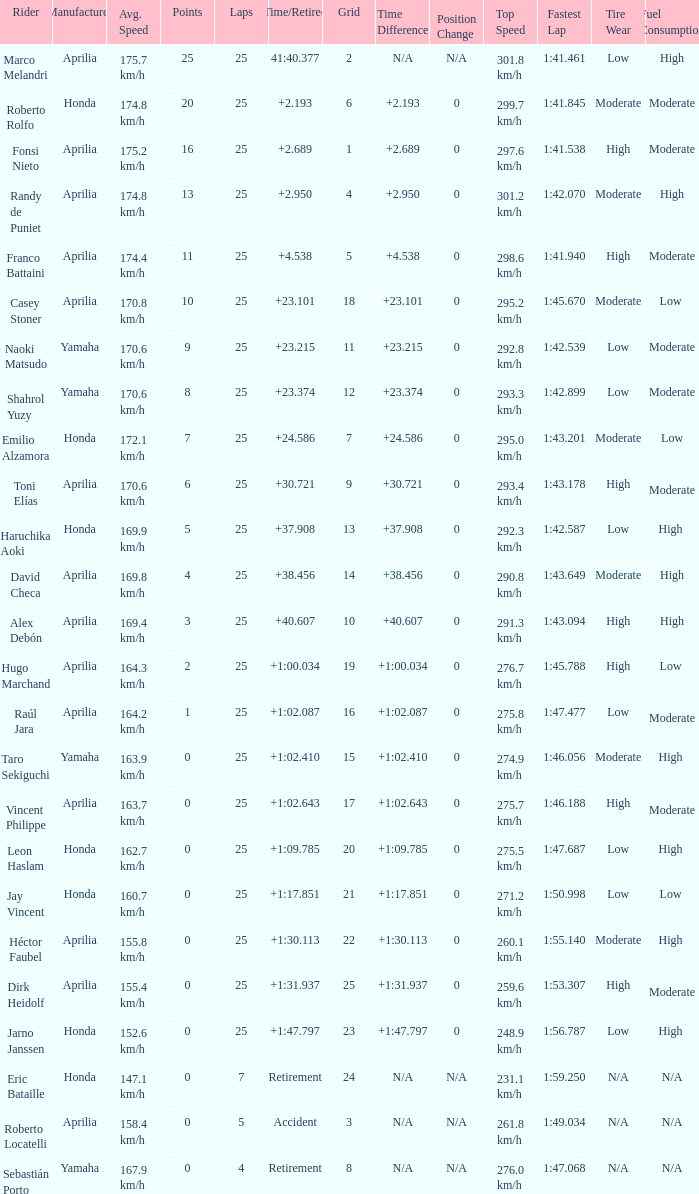Which Grid has Laps of 25, and a Manufacturer of honda, and a Time/Retired of +1:47.797? 23.0. 